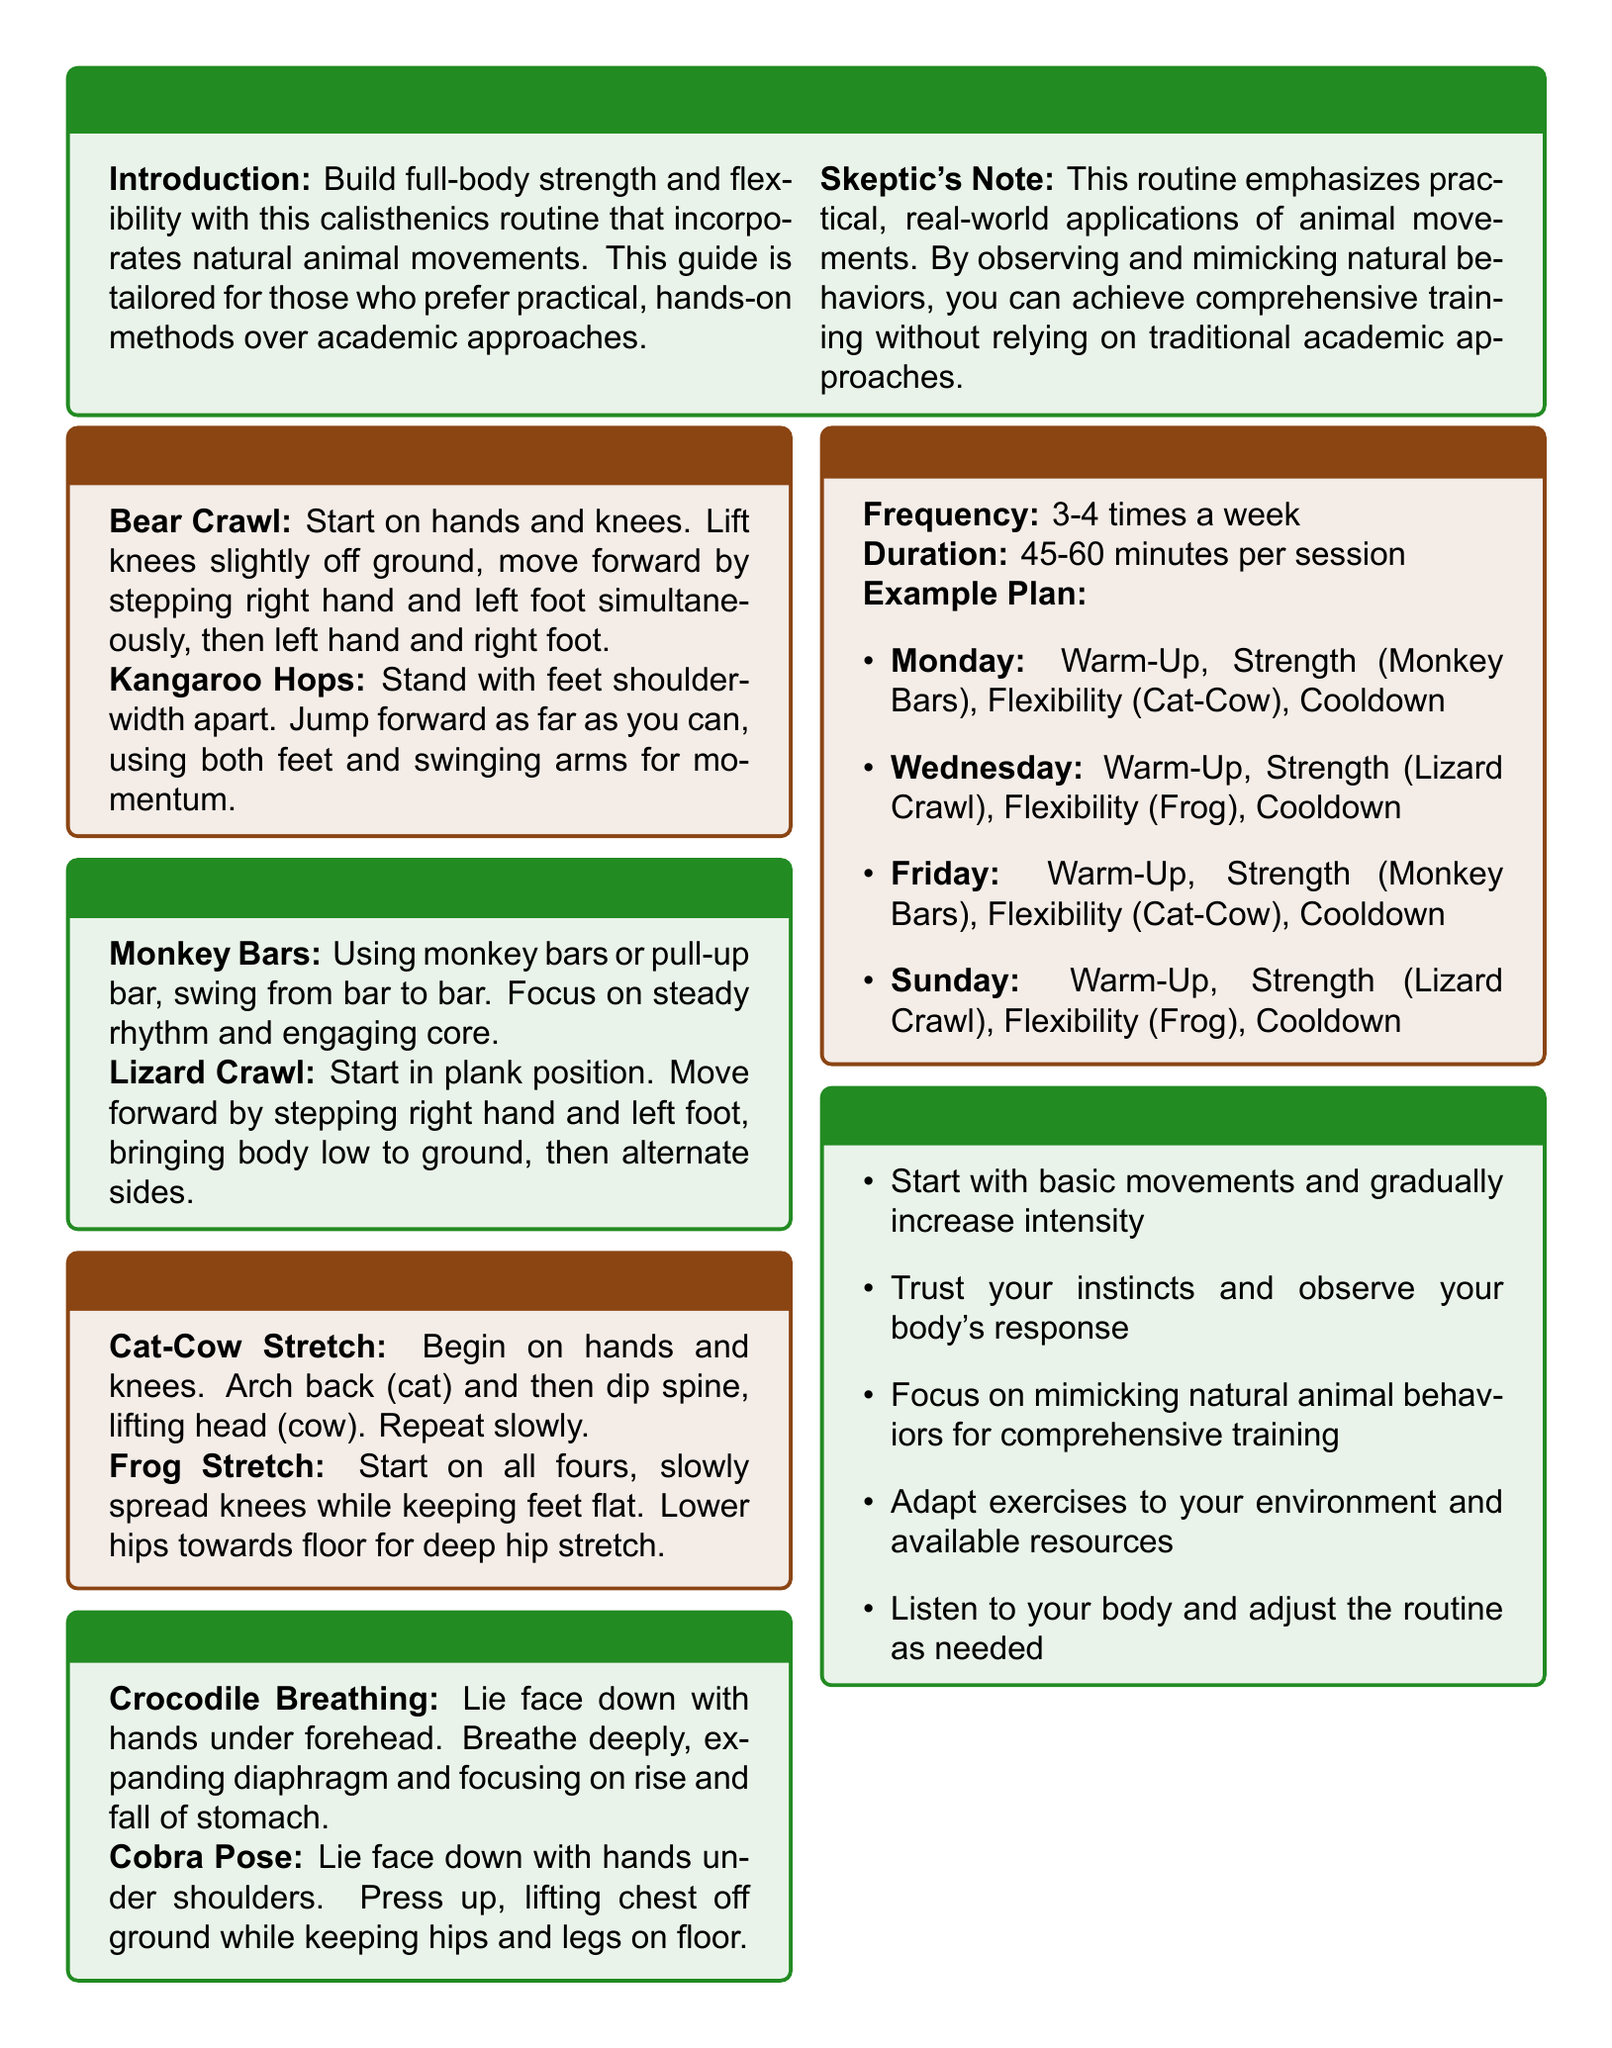What is the title of the document? The title is presented in the first section and indicates the subject of the workout plan.
Answer: Calisthenics Routines: Full-Body Strength & Flexibility How many times a week should the routines be performed? The routine structure specifies the frequency of workouts for optimal training.
Answer: 3-4 times a week What is the duration of each training session? The routine structure provides the length of time each session should last.
Answer: 45-60 minutes per session Name one flexibility exercise included in the routine. The flexibility training section lists exercises that focus on improving flexibility.
Answer: Frog Stretch What type of movements are emphasized in this workout plan? The introduction mentions the focus of this workout plan.
Answer: Natural animal movements Which exercise is recommended for the cooldown section? The cooldown section lists exercises designed to help the body relax after the workout.
Answer: Cobra Pose What is suggested to observe during workouts? The tips section provides advice related to the user's experience during exercises.
Answer: Your body's response What type of trainer is this routine tailored for? The introduction highlights the ideal audience for this workout guide.
Answer: Those who prefer practical, hands-on methods Which strength training exercise involves a bar? The strength training section specifies one exercise that uses a particular equipment type.
Answer: Monkey Bars 